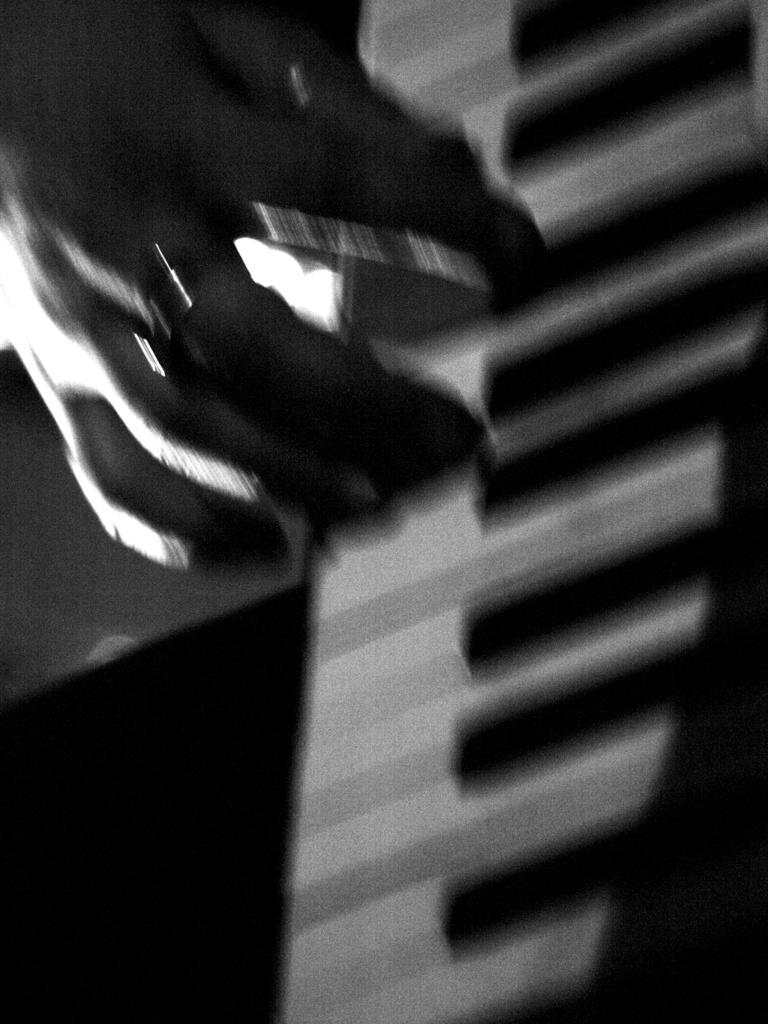What is the person's hand doing in the image? The hand is on piano keys in the image. What object is the person's hand interacting with? The hand is interacting with piano keys. Can you describe any jewelry the person is wearing in the image? The person is wearing a ring in the image. Can you tell me how many kittens are playing on the playground in the image? There are no kittens or playground present in the image; it features a person's hand on piano keys. What advice is the person giving to someone in the image? There is no indication in the image that the person is giving advice to someone. 